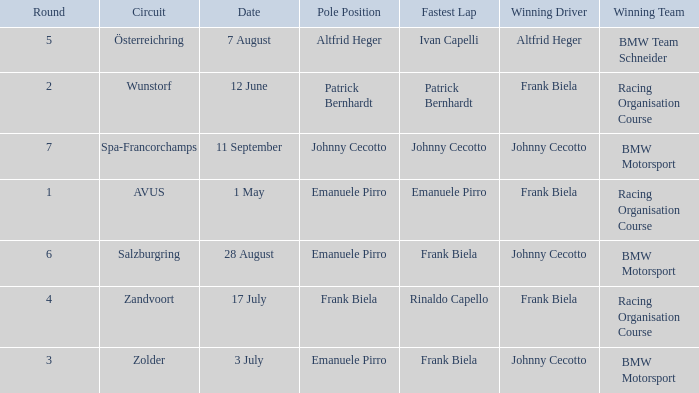Who had pole position in round 7? Johnny Cecotto. 